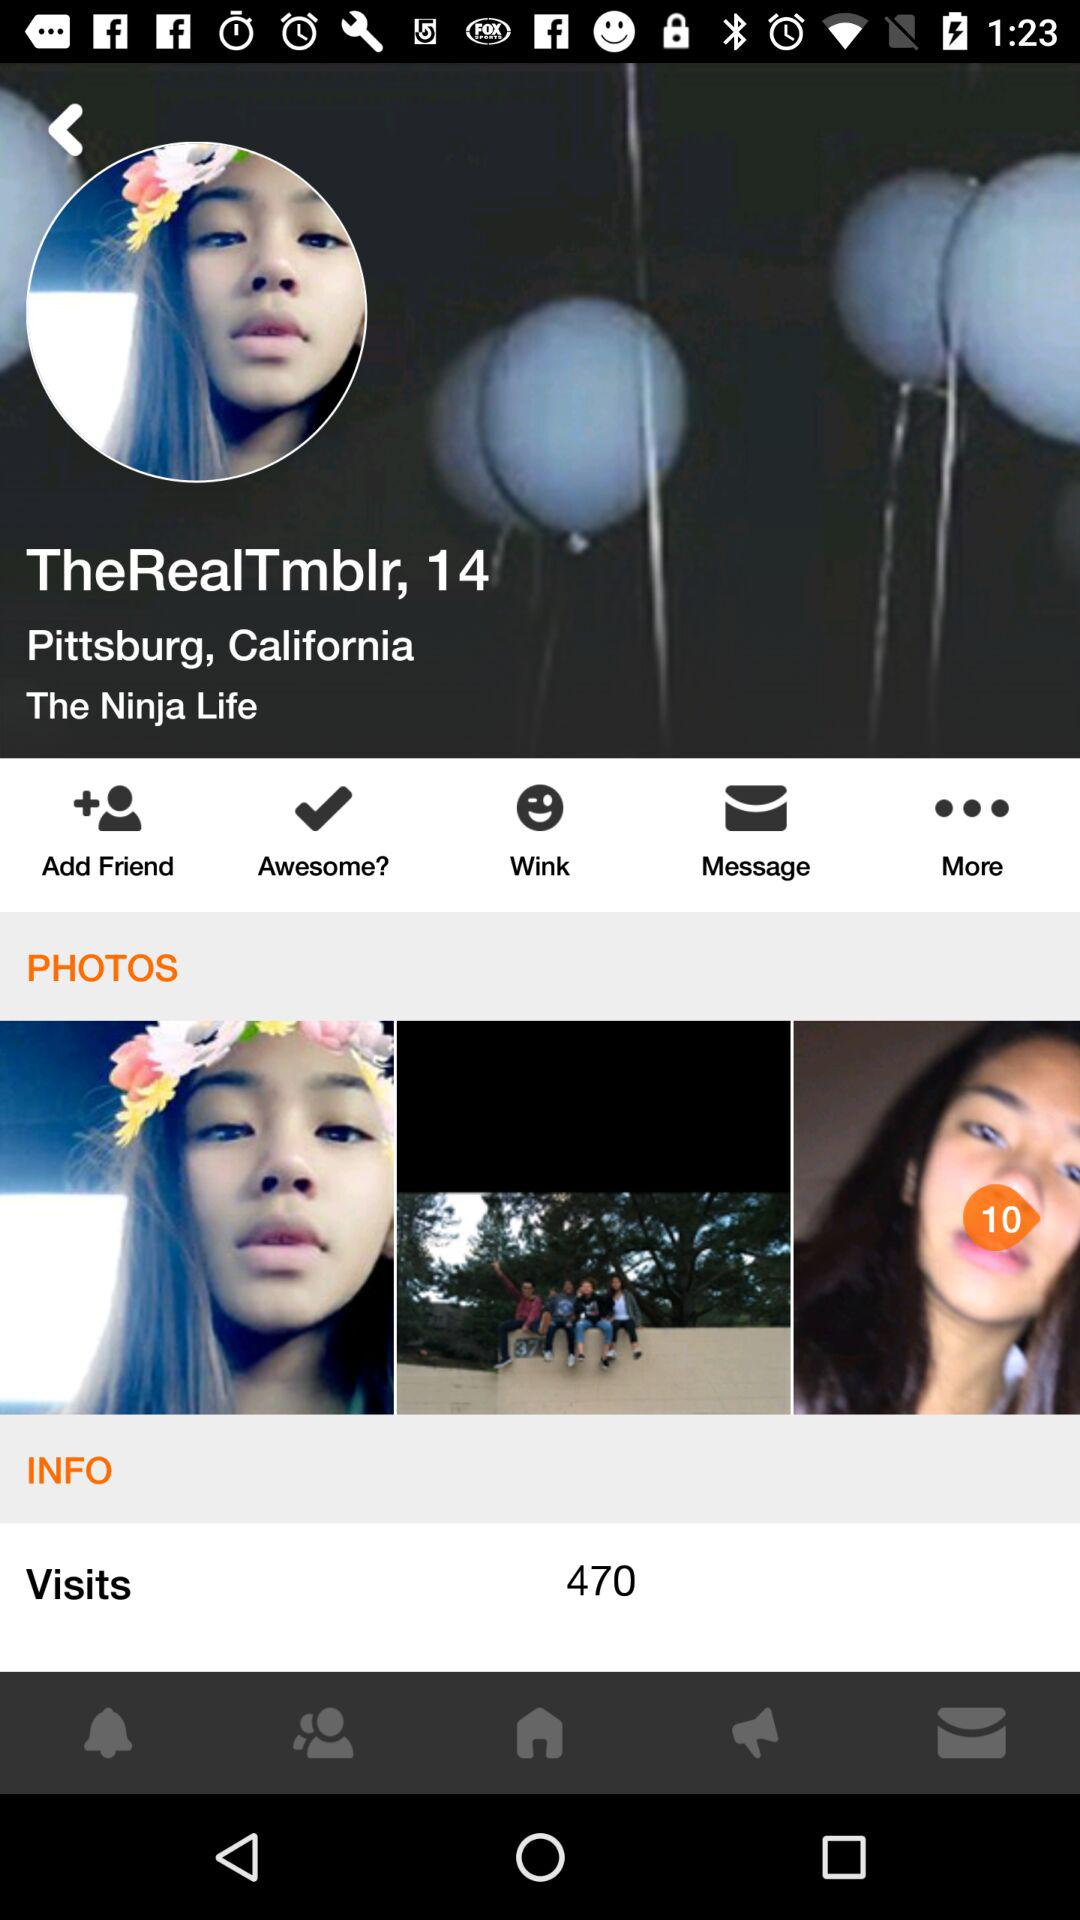How many visits in total are there on the profile? There are 470 visits in total on the profile. 